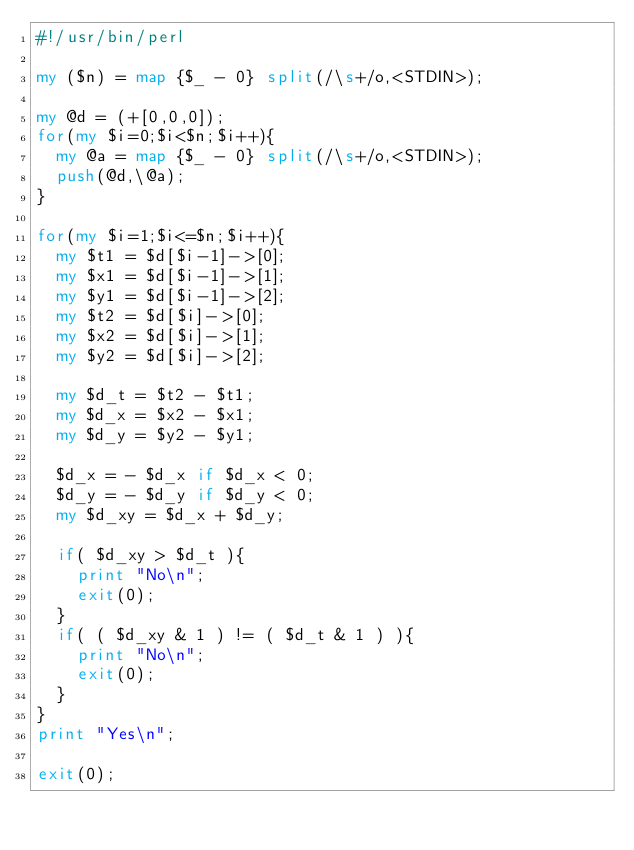<code> <loc_0><loc_0><loc_500><loc_500><_Perl_>#!/usr/bin/perl

my ($n) = map {$_ - 0} split(/\s+/o,<STDIN>);

my @d = (+[0,0,0]);
for(my $i=0;$i<$n;$i++){
  my @a = map {$_ - 0} split(/\s+/o,<STDIN>);
  push(@d,\@a);
}

for(my $i=1;$i<=$n;$i++){
  my $t1 = $d[$i-1]->[0];
  my $x1 = $d[$i-1]->[1];
  my $y1 = $d[$i-1]->[2];
  my $t2 = $d[$i]->[0];
  my $x2 = $d[$i]->[1];
  my $y2 = $d[$i]->[2];
  
  my $d_t = $t2 - $t1;
  my $d_x = $x2 - $x1;
  my $d_y = $y2 - $y1;
  
  $d_x = - $d_x if $d_x < 0;
  $d_y = - $d_y if $d_y < 0;
  my $d_xy = $d_x + $d_y;
  
  if( $d_xy > $d_t ){
    print "No\n";
    exit(0);
  }
  if( ( $d_xy & 1 ) != ( $d_t & 1 ) ){
    print "No\n";
    exit(0);
  }
}
print "Yes\n";

exit(0);

</code> 